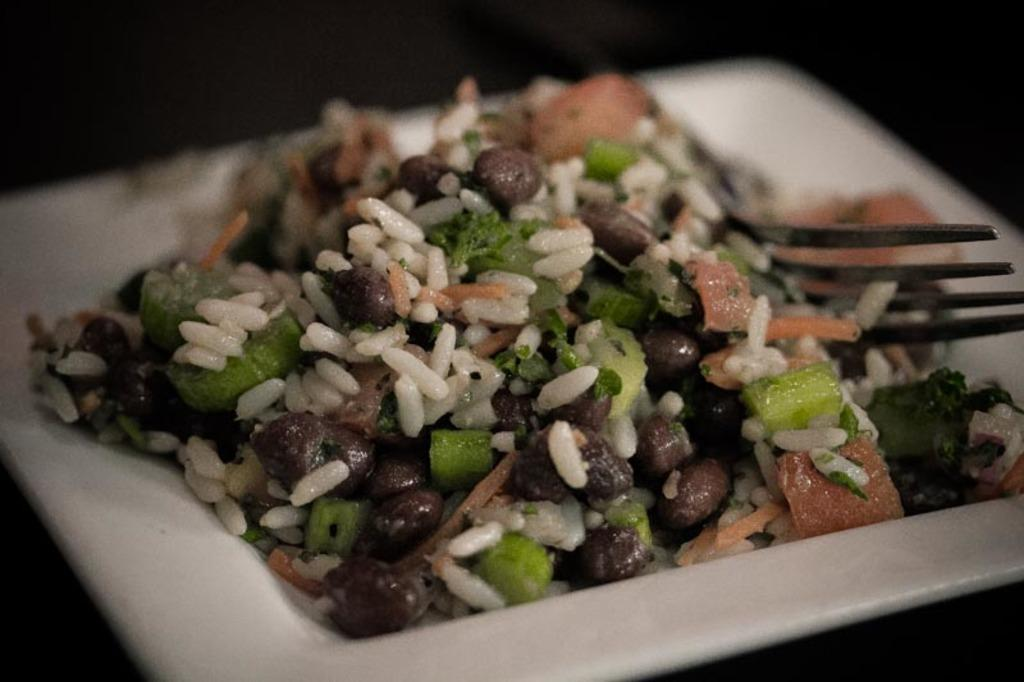What is present on the plate in the image? There is food in the image. What utensil is visible in the image? There is a fork in the image. Can you describe the plate in the image? The plate is present in the image. What type of key is used to unlock the farm in the image? There is no key, farm, or chickens present in the image. 